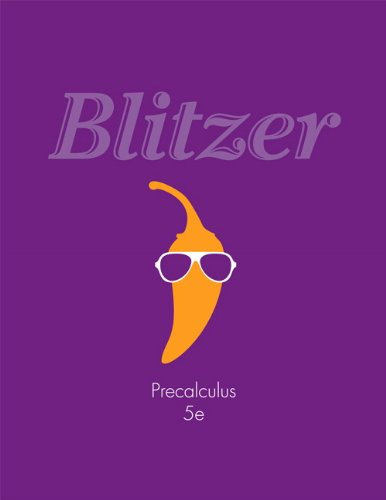Is this a judicial book? No, this is not a judicial book. It's a mathematics textbook specializing in precalculus, thus it pertains to educational content rather than legal or judiciary topics. 